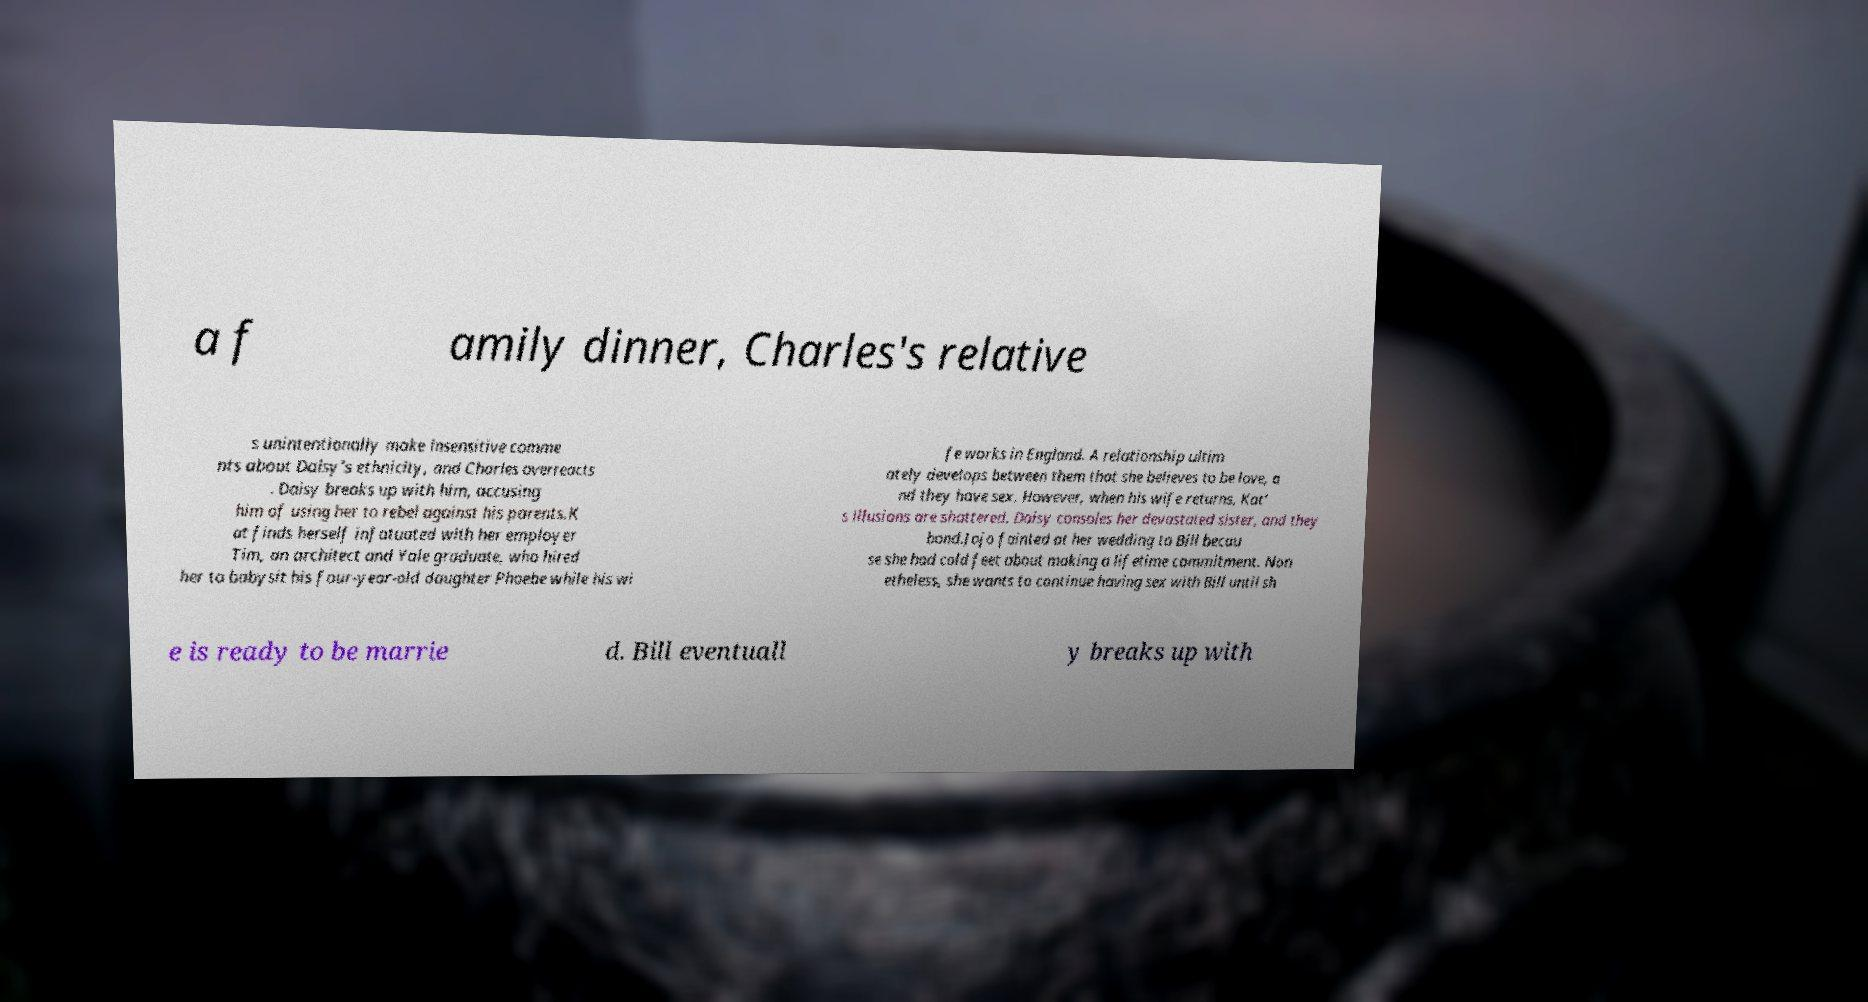Please identify and transcribe the text found in this image. a f amily dinner, Charles's relative s unintentionally make insensitive comme nts about Daisy's ethnicity, and Charles overreacts . Daisy breaks up with him, accusing him of using her to rebel against his parents.K at finds herself infatuated with her employer Tim, an architect and Yale graduate, who hired her to babysit his four-year-old daughter Phoebe while his wi fe works in England. A relationship ultim ately develops between them that she believes to be love, a nd they have sex. However, when his wife returns, Kat' s illusions are shattered. Daisy consoles her devastated sister, and they bond.Jojo fainted at her wedding to Bill becau se she had cold feet about making a lifetime commitment. Non etheless, she wants to continue having sex with Bill until sh e is ready to be marrie d. Bill eventuall y breaks up with 